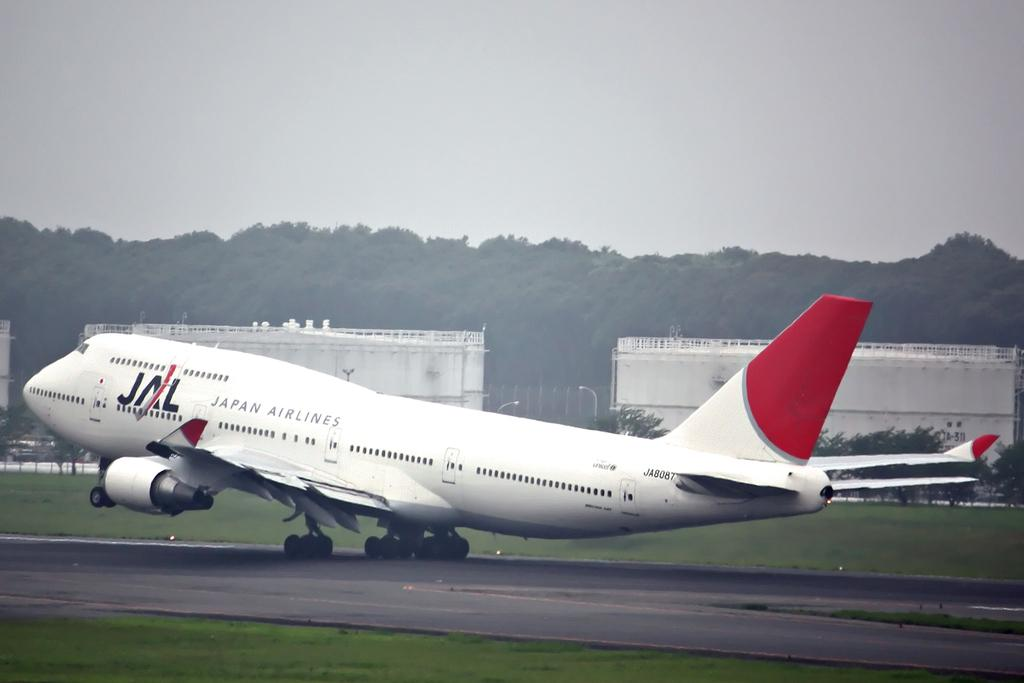What color is the airplane in the image? The airplane is white in the image. Where is the airplane located in the image? The airplane is on a runway in the image. What type of vegetation can be seen in the image? There is grass visible in the image. What other objects can be seen in the image besides the airplane? Trees, light poles, and buildings are present in the image. What is visible in the background of the image? The sky is plain and visible in the background of the image. What hobbies do the airplane's eyes enjoy in the image? Airplanes do not have eyes, so they cannot have hobbies. 